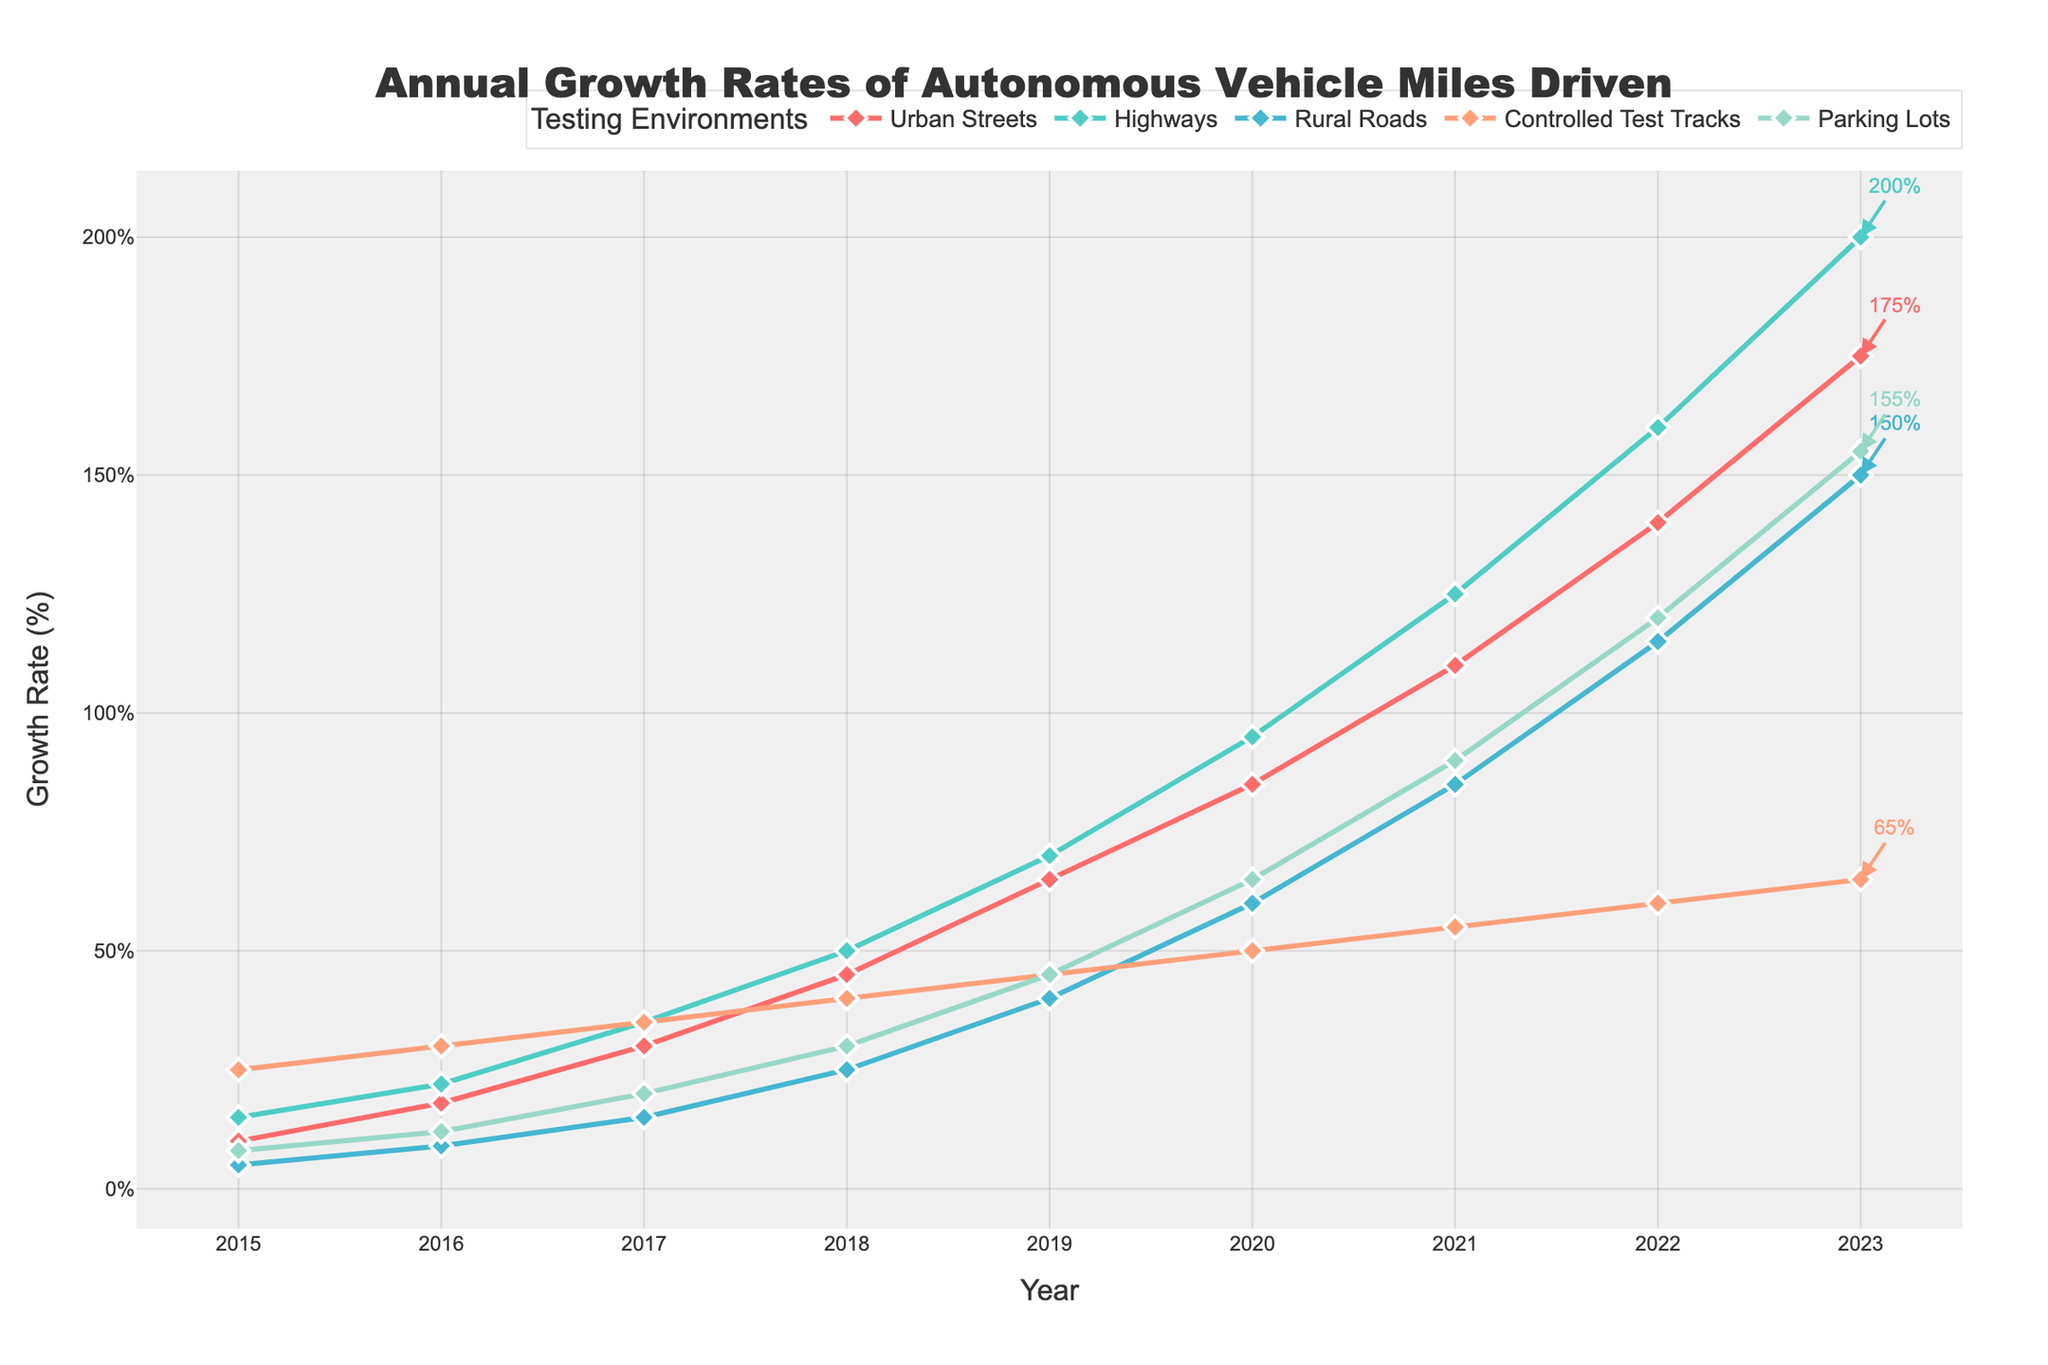Is the growth rate for Urban Streets higher in 2020 or in 2017? To determine whether the growth rate for Urban Streets is higher in 2020 or 2017, reference the values for those years. According to the figure, Urban Streets had a 2020 growth rate of 85% and a 2017 growth rate of 30%. Since 85% is higher than 30%, 2020 has the higher rate.
Answer: 2020 Which testing environment experienced the highest growth rate in 2018? To find the testing environment with the highest growth rate in 2018, compare the growth rates for all environments in that year. The growth rates in 2018 are: Urban Streets (45%), Highways (50%), Rural Roads (25%), Controlled Test Tracks (40%), and Parking Lots (30%). Highways had the highest growth rate in 2018 with 50%.
Answer: Highways What is the total growth rate for Rural Roads from 2015 to 2017? To calculate the total growth rate for Rural Roads from 2015 to 2017, sum the growth rates for 2015 (5%), 2016 (9%), and 2017 (15%). Adding these values gives 5 + 9 + 15 = 29%.
Answer: 29% By how much did the growth rate in NoParking Lots change from 2016 to 2023? To find the change in growth rate for Parking Lots from 2016 to 2023, subtract the 2016 value (12%) from the 2023 value (155%). The change is 155% - 12% = 143%.
Answer: 143% What is the average growth rate for Controlled Test Tracks over the entire period from 2015 to 2023? To find the average growth rate for Controlled Test Tracks from 2015 to 2023, first sum the growth rates for each year, 25 + 30 + 35 + 40 + 45 + 50 + 55 + 60 + 65 = 405%. Then, divide by the number of years (9). The average growth rate is 405% / 9 = 45%.
Answer: 45% Among the five testing environments, which experienced the most constant growth rate trend over the years? By analyzing the growth trends visually on the figure, Controlled Test Tracks show the least variation and most steady linear growth compared to other environments.
Answer: Controlled Test Tracks How does the growth rate of Parking Lots in 2023 compare to that of Urban Streets in 2020? Compare the growth rates of Parking Lots in 2023 (155%) to Urban Streets in 2020 (85%). Parking Lots had a higher growth rate in 2023 compared to Urban Streets in 2020.
Answer: Parking Lots in 2023 What was the percentage increase in growth rate for Highways from 2019 to 2022? Calculate the percentage increase from 2019 to 2022 by first finding the difference: 160% - 70% = 90%. Then, divide by the 2019 value and multiply by 100: (90% / 70%) * 100 = 128.57%.
Answer: 128.57% 